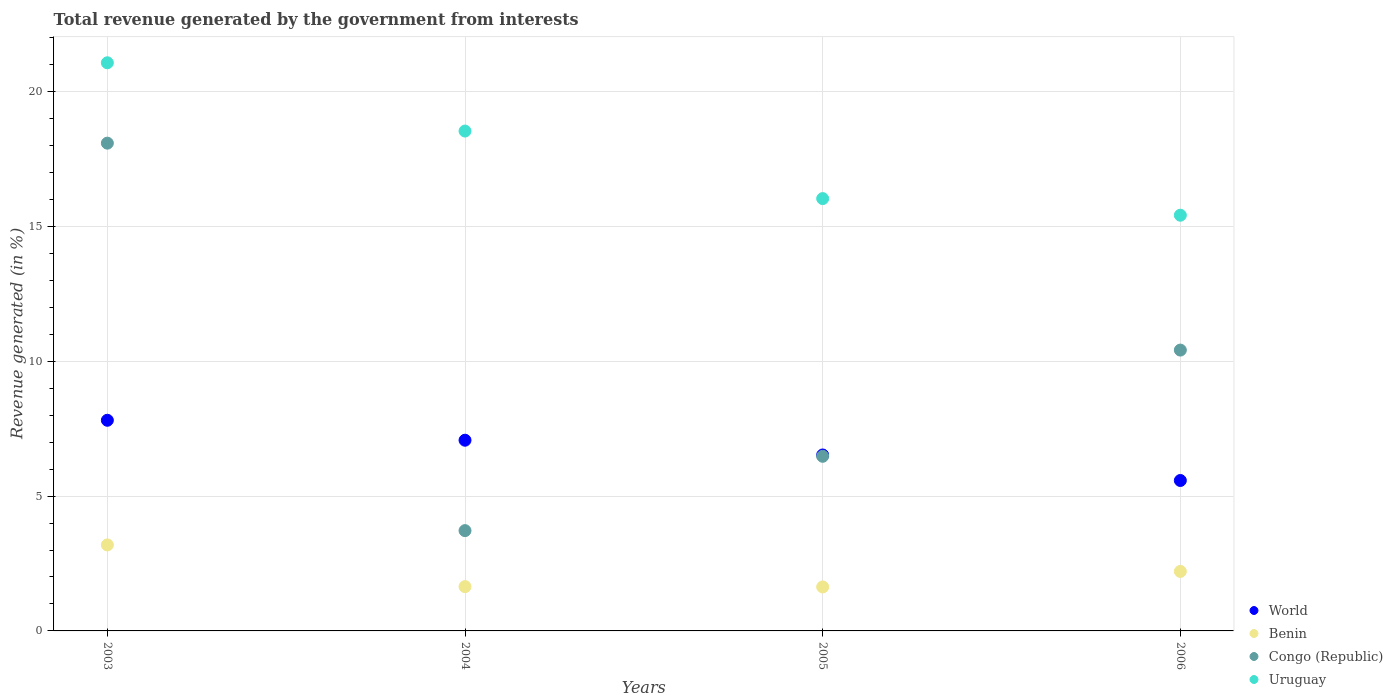How many different coloured dotlines are there?
Your answer should be compact. 4. Is the number of dotlines equal to the number of legend labels?
Make the answer very short. Yes. What is the total revenue generated in Benin in 2003?
Ensure brevity in your answer.  3.19. Across all years, what is the maximum total revenue generated in Benin?
Your answer should be compact. 3.19. Across all years, what is the minimum total revenue generated in Uruguay?
Make the answer very short. 15.42. What is the total total revenue generated in Congo (Republic) in the graph?
Make the answer very short. 38.7. What is the difference between the total revenue generated in Congo (Republic) in 2003 and that in 2006?
Ensure brevity in your answer.  7.67. What is the difference between the total revenue generated in Benin in 2006 and the total revenue generated in World in 2003?
Ensure brevity in your answer.  -5.6. What is the average total revenue generated in World per year?
Make the answer very short. 6.75. In the year 2003, what is the difference between the total revenue generated in Uruguay and total revenue generated in Benin?
Give a very brief answer. 17.88. In how many years, is the total revenue generated in World greater than 10 %?
Your response must be concise. 0. What is the ratio of the total revenue generated in Benin in 2003 to that in 2005?
Offer a terse response. 1.96. What is the difference between the highest and the second highest total revenue generated in Uruguay?
Your response must be concise. 2.53. What is the difference between the highest and the lowest total revenue generated in Uruguay?
Keep it short and to the point. 5.65. In how many years, is the total revenue generated in World greater than the average total revenue generated in World taken over all years?
Your answer should be compact. 2. Is it the case that in every year, the sum of the total revenue generated in World and total revenue generated in Uruguay  is greater than the sum of total revenue generated in Congo (Republic) and total revenue generated in Benin?
Keep it short and to the point. Yes. Is it the case that in every year, the sum of the total revenue generated in Uruguay and total revenue generated in Benin  is greater than the total revenue generated in World?
Provide a succinct answer. Yes. Is the total revenue generated in World strictly greater than the total revenue generated in Uruguay over the years?
Your answer should be compact. No. Are the values on the major ticks of Y-axis written in scientific E-notation?
Provide a short and direct response. No. How are the legend labels stacked?
Offer a very short reply. Vertical. What is the title of the graph?
Provide a short and direct response. Total revenue generated by the government from interests. What is the label or title of the Y-axis?
Ensure brevity in your answer.  Revenue generated (in %). What is the Revenue generated (in %) of World in 2003?
Your response must be concise. 7.81. What is the Revenue generated (in %) of Benin in 2003?
Give a very brief answer. 3.19. What is the Revenue generated (in %) of Congo (Republic) in 2003?
Your response must be concise. 18.09. What is the Revenue generated (in %) of Uruguay in 2003?
Your response must be concise. 21.07. What is the Revenue generated (in %) in World in 2004?
Make the answer very short. 7.07. What is the Revenue generated (in %) of Benin in 2004?
Keep it short and to the point. 1.64. What is the Revenue generated (in %) in Congo (Republic) in 2004?
Give a very brief answer. 3.72. What is the Revenue generated (in %) in Uruguay in 2004?
Your answer should be compact. 18.54. What is the Revenue generated (in %) of World in 2005?
Keep it short and to the point. 6.52. What is the Revenue generated (in %) in Benin in 2005?
Your response must be concise. 1.63. What is the Revenue generated (in %) of Congo (Republic) in 2005?
Provide a short and direct response. 6.48. What is the Revenue generated (in %) in Uruguay in 2005?
Give a very brief answer. 16.03. What is the Revenue generated (in %) in World in 2006?
Your answer should be compact. 5.58. What is the Revenue generated (in %) of Benin in 2006?
Ensure brevity in your answer.  2.21. What is the Revenue generated (in %) in Congo (Republic) in 2006?
Provide a succinct answer. 10.41. What is the Revenue generated (in %) in Uruguay in 2006?
Offer a very short reply. 15.42. Across all years, what is the maximum Revenue generated (in %) in World?
Keep it short and to the point. 7.81. Across all years, what is the maximum Revenue generated (in %) in Benin?
Provide a short and direct response. 3.19. Across all years, what is the maximum Revenue generated (in %) of Congo (Republic)?
Your answer should be compact. 18.09. Across all years, what is the maximum Revenue generated (in %) of Uruguay?
Provide a short and direct response. 21.07. Across all years, what is the minimum Revenue generated (in %) in World?
Keep it short and to the point. 5.58. Across all years, what is the minimum Revenue generated (in %) of Benin?
Provide a short and direct response. 1.63. Across all years, what is the minimum Revenue generated (in %) in Congo (Republic)?
Offer a very short reply. 3.72. Across all years, what is the minimum Revenue generated (in %) of Uruguay?
Provide a succinct answer. 15.42. What is the total Revenue generated (in %) in World in the graph?
Ensure brevity in your answer.  26.99. What is the total Revenue generated (in %) in Benin in the graph?
Your answer should be very brief. 8.67. What is the total Revenue generated (in %) in Congo (Republic) in the graph?
Make the answer very short. 38.7. What is the total Revenue generated (in %) in Uruguay in the graph?
Offer a very short reply. 71.05. What is the difference between the Revenue generated (in %) in World in 2003 and that in 2004?
Provide a short and direct response. 0.74. What is the difference between the Revenue generated (in %) of Benin in 2003 and that in 2004?
Your answer should be compact. 1.55. What is the difference between the Revenue generated (in %) of Congo (Republic) in 2003 and that in 2004?
Give a very brief answer. 14.37. What is the difference between the Revenue generated (in %) of Uruguay in 2003 and that in 2004?
Your answer should be very brief. 2.53. What is the difference between the Revenue generated (in %) in World in 2003 and that in 2005?
Your response must be concise. 1.29. What is the difference between the Revenue generated (in %) in Benin in 2003 and that in 2005?
Keep it short and to the point. 1.56. What is the difference between the Revenue generated (in %) in Congo (Republic) in 2003 and that in 2005?
Ensure brevity in your answer.  11.61. What is the difference between the Revenue generated (in %) in Uruguay in 2003 and that in 2005?
Make the answer very short. 5.04. What is the difference between the Revenue generated (in %) of World in 2003 and that in 2006?
Your response must be concise. 2.23. What is the difference between the Revenue generated (in %) in Benin in 2003 and that in 2006?
Make the answer very short. 0.98. What is the difference between the Revenue generated (in %) of Congo (Republic) in 2003 and that in 2006?
Ensure brevity in your answer.  7.67. What is the difference between the Revenue generated (in %) in Uruguay in 2003 and that in 2006?
Provide a short and direct response. 5.65. What is the difference between the Revenue generated (in %) in World in 2004 and that in 2005?
Make the answer very short. 0.55. What is the difference between the Revenue generated (in %) of Benin in 2004 and that in 2005?
Provide a short and direct response. 0.01. What is the difference between the Revenue generated (in %) in Congo (Republic) in 2004 and that in 2005?
Your answer should be very brief. -2.76. What is the difference between the Revenue generated (in %) of Uruguay in 2004 and that in 2005?
Provide a short and direct response. 2.5. What is the difference between the Revenue generated (in %) of World in 2004 and that in 2006?
Your response must be concise. 1.49. What is the difference between the Revenue generated (in %) in Benin in 2004 and that in 2006?
Provide a succinct answer. -0.56. What is the difference between the Revenue generated (in %) of Congo (Republic) in 2004 and that in 2006?
Keep it short and to the point. -6.7. What is the difference between the Revenue generated (in %) in Uruguay in 2004 and that in 2006?
Your response must be concise. 3.12. What is the difference between the Revenue generated (in %) of World in 2005 and that in 2006?
Make the answer very short. 0.95. What is the difference between the Revenue generated (in %) of Benin in 2005 and that in 2006?
Ensure brevity in your answer.  -0.58. What is the difference between the Revenue generated (in %) of Congo (Republic) in 2005 and that in 2006?
Provide a succinct answer. -3.94. What is the difference between the Revenue generated (in %) in Uruguay in 2005 and that in 2006?
Give a very brief answer. 0.62. What is the difference between the Revenue generated (in %) in World in 2003 and the Revenue generated (in %) in Benin in 2004?
Provide a succinct answer. 6.17. What is the difference between the Revenue generated (in %) of World in 2003 and the Revenue generated (in %) of Congo (Republic) in 2004?
Provide a short and direct response. 4.09. What is the difference between the Revenue generated (in %) of World in 2003 and the Revenue generated (in %) of Uruguay in 2004?
Offer a terse response. -10.73. What is the difference between the Revenue generated (in %) in Benin in 2003 and the Revenue generated (in %) in Congo (Republic) in 2004?
Make the answer very short. -0.53. What is the difference between the Revenue generated (in %) in Benin in 2003 and the Revenue generated (in %) in Uruguay in 2004?
Ensure brevity in your answer.  -15.35. What is the difference between the Revenue generated (in %) of Congo (Republic) in 2003 and the Revenue generated (in %) of Uruguay in 2004?
Provide a succinct answer. -0.45. What is the difference between the Revenue generated (in %) of World in 2003 and the Revenue generated (in %) of Benin in 2005?
Your answer should be very brief. 6.18. What is the difference between the Revenue generated (in %) in World in 2003 and the Revenue generated (in %) in Congo (Republic) in 2005?
Make the answer very short. 1.34. What is the difference between the Revenue generated (in %) in World in 2003 and the Revenue generated (in %) in Uruguay in 2005?
Give a very brief answer. -8.22. What is the difference between the Revenue generated (in %) of Benin in 2003 and the Revenue generated (in %) of Congo (Republic) in 2005?
Offer a terse response. -3.29. What is the difference between the Revenue generated (in %) in Benin in 2003 and the Revenue generated (in %) in Uruguay in 2005?
Ensure brevity in your answer.  -12.84. What is the difference between the Revenue generated (in %) in Congo (Republic) in 2003 and the Revenue generated (in %) in Uruguay in 2005?
Offer a terse response. 2.06. What is the difference between the Revenue generated (in %) in World in 2003 and the Revenue generated (in %) in Benin in 2006?
Your answer should be very brief. 5.6. What is the difference between the Revenue generated (in %) in World in 2003 and the Revenue generated (in %) in Congo (Republic) in 2006?
Provide a short and direct response. -2.6. What is the difference between the Revenue generated (in %) in World in 2003 and the Revenue generated (in %) in Uruguay in 2006?
Your answer should be compact. -7.6. What is the difference between the Revenue generated (in %) of Benin in 2003 and the Revenue generated (in %) of Congo (Republic) in 2006?
Ensure brevity in your answer.  -7.22. What is the difference between the Revenue generated (in %) of Benin in 2003 and the Revenue generated (in %) of Uruguay in 2006?
Give a very brief answer. -12.23. What is the difference between the Revenue generated (in %) in Congo (Republic) in 2003 and the Revenue generated (in %) in Uruguay in 2006?
Your response must be concise. 2.67. What is the difference between the Revenue generated (in %) of World in 2004 and the Revenue generated (in %) of Benin in 2005?
Offer a terse response. 5.44. What is the difference between the Revenue generated (in %) in World in 2004 and the Revenue generated (in %) in Congo (Republic) in 2005?
Offer a terse response. 0.6. What is the difference between the Revenue generated (in %) in World in 2004 and the Revenue generated (in %) in Uruguay in 2005?
Your response must be concise. -8.96. What is the difference between the Revenue generated (in %) of Benin in 2004 and the Revenue generated (in %) of Congo (Republic) in 2005?
Give a very brief answer. -4.83. What is the difference between the Revenue generated (in %) of Benin in 2004 and the Revenue generated (in %) of Uruguay in 2005?
Provide a short and direct response. -14.39. What is the difference between the Revenue generated (in %) of Congo (Republic) in 2004 and the Revenue generated (in %) of Uruguay in 2005?
Keep it short and to the point. -12.31. What is the difference between the Revenue generated (in %) in World in 2004 and the Revenue generated (in %) in Benin in 2006?
Your answer should be very brief. 4.87. What is the difference between the Revenue generated (in %) in World in 2004 and the Revenue generated (in %) in Congo (Republic) in 2006?
Keep it short and to the point. -3.34. What is the difference between the Revenue generated (in %) of World in 2004 and the Revenue generated (in %) of Uruguay in 2006?
Your answer should be very brief. -8.34. What is the difference between the Revenue generated (in %) in Benin in 2004 and the Revenue generated (in %) in Congo (Republic) in 2006?
Your answer should be compact. -8.77. What is the difference between the Revenue generated (in %) of Benin in 2004 and the Revenue generated (in %) of Uruguay in 2006?
Give a very brief answer. -13.77. What is the difference between the Revenue generated (in %) in Congo (Republic) in 2004 and the Revenue generated (in %) in Uruguay in 2006?
Give a very brief answer. -11.7. What is the difference between the Revenue generated (in %) in World in 2005 and the Revenue generated (in %) in Benin in 2006?
Ensure brevity in your answer.  4.32. What is the difference between the Revenue generated (in %) of World in 2005 and the Revenue generated (in %) of Congo (Republic) in 2006?
Keep it short and to the point. -3.89. What is the difference between the Revenue generated (in %) of World in 2005 and the Revenue generated (in %) of Uruguay in 2006?
Give a very brief answer. -8.89. What is the difference between the Revenue generated (in %) in Benin in 2005 and the Revenue generated (in %) in Congo (Republic) in 2006?
Provide a short and direct response. -8.78. What is the difference between the Revenue generated (in %) of Benin in 2005 and the Revenue generated (in %) of Uruguay in 2006?
Give a very brief answer. -13.79. What is the difference between the Revenue generated (in %) of Congo (Republic) in 2005 and the Revenue generated (in %) of Uruguay in 2006?
Your response must be concise. -8.94. What is the average Revenue generated (in %) of World per year?
Your answer should be very brief. 6.75. What is the average Revenue generated (in %) in Benin per year?
Make the answer very short. 2.17. What is the average Revenue generated (in %) in Congo (Republic) per year?
Your answer should be compact. 9.67. What is the average Revenue generated (in %) of Uruguay per year?
Keep it short and to the point. 17.76. In the year 2003, what is the difference between the Revenue generated (in %) of World and Revenue generated (in %) of Benin?
Give a very brief answer. 4.62. In the year 2003, what is the difference between the Revenue generated (in %) in World and Revenue generated (in %) in Congo (Republic)?
Ensure brevity in your answer.  -10.28. In the year 2003, what is the difference between the Revenue generated (in %) in World and Revenue generated (in %) in Uruguay?
Ensure brevity in your answer.  -13.26. In the year 2003, what is the difference between the Revenue generated (in %) in Benin and Revenue generated (in %) in Congo (Republic)?
Your answer should be compact. -14.9. In the year 2003, what is the difference between the Revenue generated (in %) in Benin and Revenue generated (in %) in Uruguay?
Provide a short and direct response. -17.88. In the year 2003, what is the difference between the Revenue generated (in %) of Congo (Republic) and Revenue generated (in %) of Uruguay?
Keep it short and to the point. -2.98. In the year 2004, what is the difference between the Revenue generated (in %) of World and Revenue generated (in %) of Benin?
Make the answer very short. 5.43. In the year 2004, what is the difference between the Revenue generated (in %) of World and Revenue generated (in %) of Congo (Republic)?
Ensure brevity in your answer.  3.35. In the year 2004, what is the difference between the Revenue generated (in %) in World and Revenue generated (in %) in Uruguay?
Provide a succinct answer. -11.46. In the year 2004, what is the difference between the Revenue generated (in %) in Benin and Revenue generated (in %) in Congo (Republic)?
Give a very brief answer. -2.08. In the year 2004, what is the difference between the Revenue generated (in %) in Benin and Revenue generated (in %) in Uruguay?
Provide a succinct answer. -16.89. In the year 2004, what is the difference between the Revenue generated (in %) of Congo (Republic) and Revenue generated (in %) of Uruguay?
Offer a terse response. -14.82. In the year 2005, what is the difference between the Revenue generated (in %) in World and Revenue generated (in %) in Benin?
Give a very brief answer. 4.89. In the year 2005, what is the difference between the Revenue generated (in %) in World and Revenue generated (in %) in Congo (Republic)?
Your answer should be very brief. 0.05. In the year 2005, what is the difference between the Revenue generated (in %) of World and Revenue generated (in %) of Uruguay?
Provide a succinct answer. -9.51. In the year 2005, what is the difference between the Revenue generated (in %) in Benin and Revenue generated (in %) in Congo (Republic)?
Your response must be concise. -4.85. In the year 2005, what is the difference between the Revenue generated (in %) of Benin and Revenue generated (in %) of Uruguay?
Give a very brief answer. -14.4. In the year 2005, what is the difference between the Revenue generated (in %) in Congo (Republic) and Revenue generated (in %) in Uruguay?
Your answer should be very brief. -9.56. In the year 2006, what is the difference between the Revenue generated (in %) in World and Revenue generated (in %) in Benin?
Give a very brief answer. 3.37. In the year 2006, what is the difference between the Revenue generated (in %) of World and Revenue generated (in %) of Congo (Republic)?
Offer a terse response. -4.84. In the year 2006, what is the difference between the Revenue generated (in %) in World and Revenue generated (in %) in Uruguay?
Provide a short and direct response. -9.84. In the year 2006, what is the difference between the Revenue generated (in %) in Benin and Revenue generated (in %) in Congo (Republic)?
Offer a very short reply. -8.21. In the year 2006, what is the difference between the Revenue generated (in %) of Benin and Revenue generated (in %) of Uruguay?
Ensure brevity in your answer.  -13.21. In the year 2006, what is the difference between the Revenue generated (in %) of Congo (Republic) and Revenue generated (in %) of Uruguay?
Your answer should be very brief. -5. What is the ratio of the Revenue generated (in %) in World in 2003 to that in 2004?
Give a very brief answer. 1.1. What is the ratio of the Revenue generated (in %) of Benin in 2003 to that in 2004?
Your response must be concise. 1.94. What is the ratio of the Revenue generated (in %) of Congo (Republic) in 2003 to that in 2004?
Offer a terse response. 4.86. What is the ratio of the Revenue generated (in %) of Uruguay in 2003 to that in 2004?
Offer a very short reply. 1.14. What is the ratio of the Revenue generated (in %) in World in 2003 to that in 2005?
Give a very brief answer. 1.2. What is the ratio of the Revenue generated (in %) in Benin in 2003 to that in 2005?
Your answer should be compact. 1.96. What is the ratio of the Revenue generated (in %) in Congo (Republic) in 2003 to that in 2005?
Provide a short and direct response. 2.79. What is the ratio of the Revenue generated (in %) in Uruguay in 2003 to that in 2005?
Provide a short and direct response. 1.31. What is the ratio of the Revenue generated (in %) in World in 2003 to that in 2006?
Keep it short and to the point. 1.4. What is the ratio of the Revenue generated (in %) of Benin in 2003 to that in 2006?
Provide a short and direct response. 1.45. What is the ratio of the Revenue generated (in %) in Congo (Republic) in 2003 to that in 2006?
Offer a very short reply. 1.74. What is the ratio of the Revenue generated (in %) of Uruguay in 2003 to that in 2006?
Make the answer very short. 1.37. What is the ratio of the Revenue generated (in %) in World in 2004 to that in 2005?
Provide a short and direct response. 1.08. What is the ratio of the Revenue generated (in %) of Benin in 2004 to that in 2005?
Provide a succinct answer. 1.01. What is the ratio of the Revenue generated (in %) of Congo (Republic) in 2004 to that in 2005?
Your answer should be compact. 0.57. What is the ratio of the Revenue generated (in %) of Uruguay in 2004 to that in 2005?
Offer a terse response. 1.16. What is the ratio of the Revenue generated (in %) in World in 2004 to that in 2006?
Keep it short and to the point. 1.27. What is the ratio of the Revenue generated (in %) in Benin in 2004 to that in 2006?
Offer a terse response. 0.74. What is the ratio of the Revenue generated (in %) of Congo (Republic) in 2004 to that in 2006?
Provide a short and direct response. 0.36. What is the ratio of the Revenue generated (in %) of Uruguay in 2004 to that in 2006?
Your answer should be very brief. 1.2. What is the ratio of the Revenue generated (in %) in World in 2005 to that in 2006?
Make the answer very short. 1.17. What is the ratio of the Revenue generated (in %) in Benin in 2005 to that in 2006?
Offer a terse response. 0.74. What is the ratio of the Revenue generated (in %) in Congo (Republic) in 2005 to that in 2006?
Provide a short and direct response. 0.62. What is the difference between the highest and the second highest Revenue generated (in %) of World?
Your answer should be compact. 0.74. What is the difference between the highest and the second highest Revenue generated (in %) in Benin?
Your response must be concise. 0.98. What is the difference between the highest and the second highest Revenue generated (in %) in Congo (Republic)?
Ensure brevity in your answer.  7.67. What is the difference between the highest and the second highest Revenue generated (in %) in Uruguay?
Provide a short and direct response. 2.53. What is the difference between the highest and the lowest Revenue generated (in %) in World?
Provide a succinct answer. 2.23. What is the difference between the highest and the lowest Revenue generated (in %) in Benin?
Give a very brief answer. 1.56. What is the difference between the highest and the lowest Revenue generated (in %) of Congo (Republic)?
Give a very brief answer. 14.37. What is the difference between the highest and the lowest Revenue generated (in %) of Uruguay?
Offer a terse response. 5.65. 